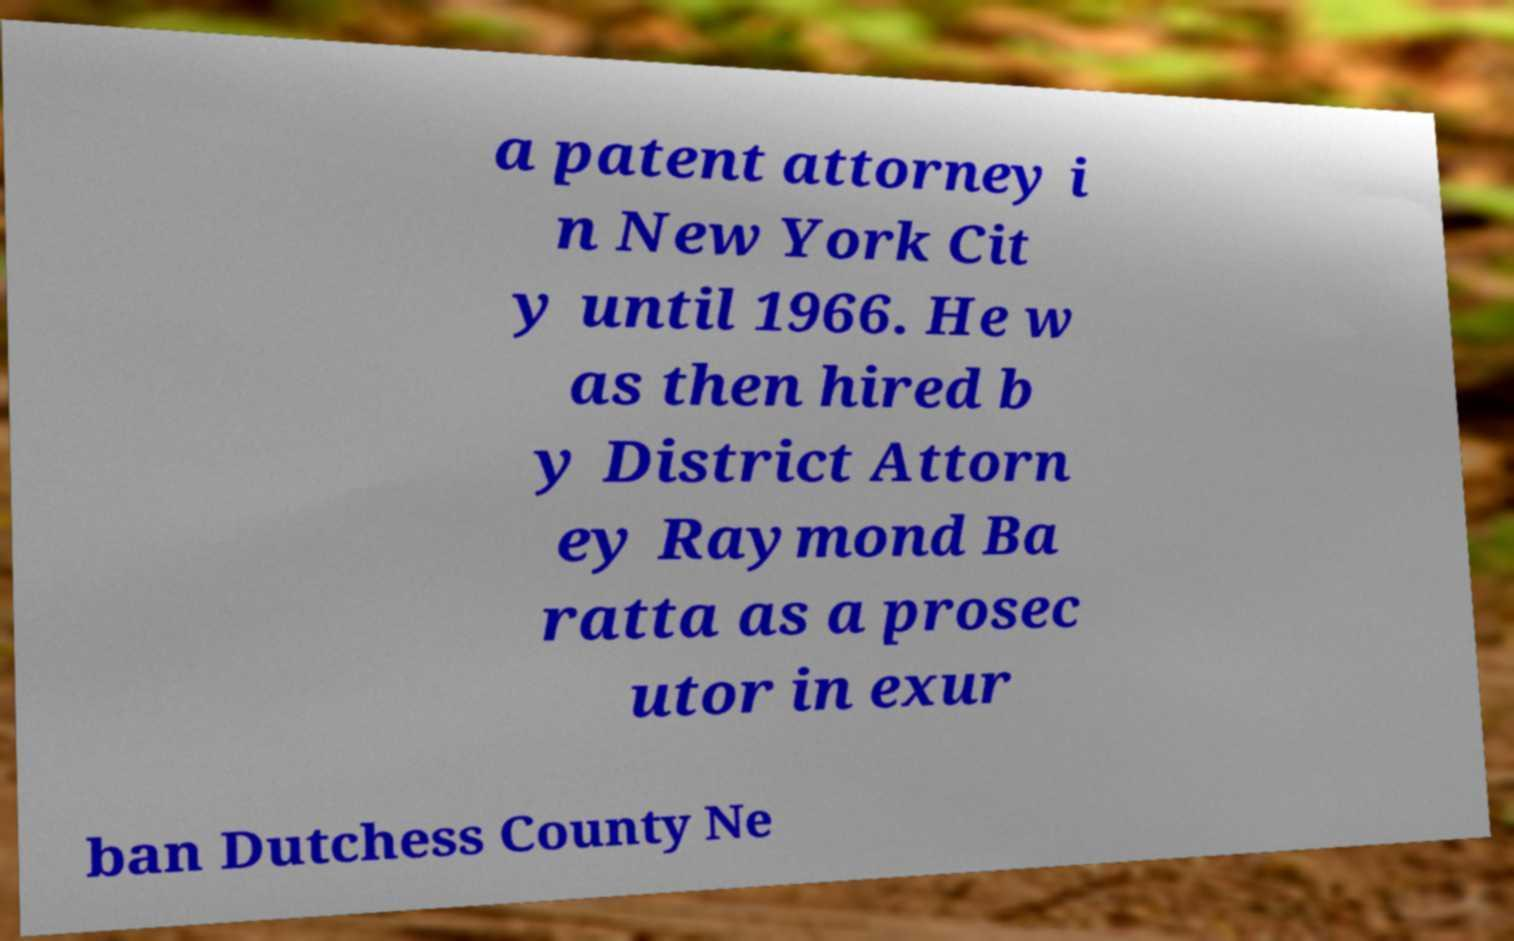Could you assist in decoding the text presented in this image and type it out clearly? a patent attorney i n New York Cit y until 1966. He w as then hired b y District Attorn ey Raymond Ba ratta as a prosec utor in exur ban Dutchess County Ne 